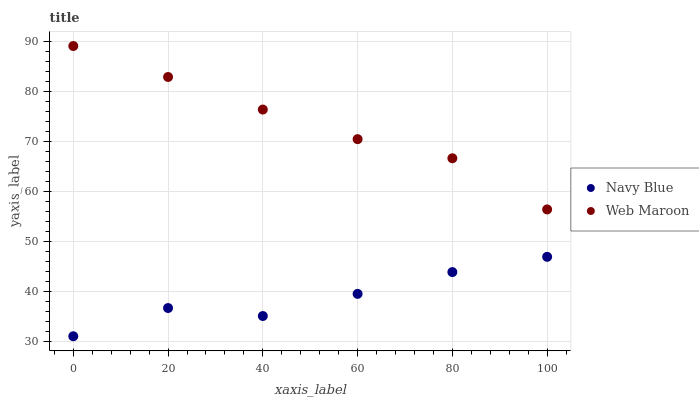Does Navy Blue have the minimum area under the curve?
Answer yes or no. Yes. Does Web Maroon have the maximum area under the curve?
Answer yes or no. Yes. Does Web Maroon have the minimum area under the curve?
Answer yes or no. No. Is Web Maroon the smoothest?
Answer yes or no. Yes. Is Navy Blue the roughest?
Answer yes or no. Yes. Is Web Maroon the roughest?
Answer yes or no. No. Does Navy Blue have the lowest value?
Answer yes or no. Yes. Does Web Maroon have the lowest value?
Answer yes or no. No. Does Web Maroon have the highest value?
Answer yes or no. Yes. Is Navy Blue less than Web Maroon?
Answer yes or no. Yes. Is Web Maroon greater than Navy Blue?
Answer yes or no. Yes. Does Navy Blue intersect Web Maroon?
Answer yes or no. No. 